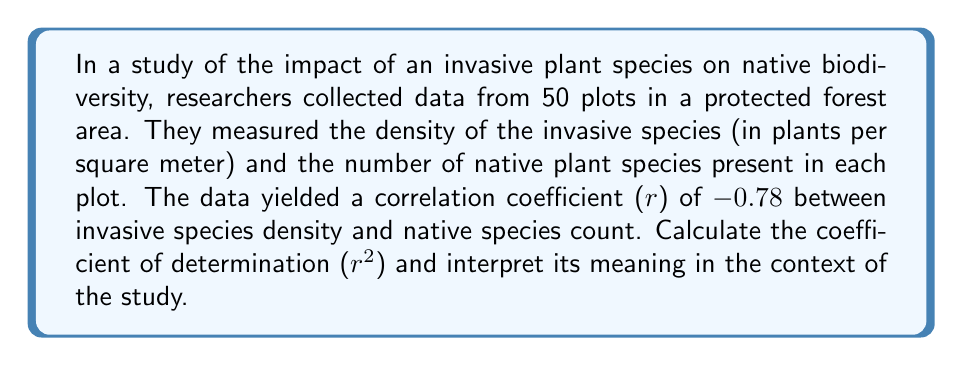Can you solve this math problem? To solve this problem, we'll follow these steps:

1) The correlation coefficient (r) is given as -0.78.

2) The coefficient of determination (r^2) is calculated by squaring the correlation coefficient:

   $$r^2 = (-0.78)^2 = 0.6084$$

3) To convert to a percentage, we multiply by 100:

   $$0.6084 * 100 = 60.84\%$$

4) Interpretation: The coefficient of determination (r^2) represents the proportion of the variance in the dependent variable (native species count) that is predictable from the independent variable (invasive species density).

   In this case, 60.84% of the variability in native species count can be explained by the linear relationship with invasive species density. This suggests a strong negative relationship between the two variables, indicating that as invasive species density increases, native species count tends to decrease.

5) However, it's crucial to note that correlation does not imply causation. While there's a strong relationship, other factors could be influencing this association. As an environmental science student, you should consider the complexity of ecosystems and the potential for confounding variables.
Answer: $r^2 = 0.6084$ or 60.84%; This indicates that 60.84% of the variation in native species count can be explained by invasive species density. 